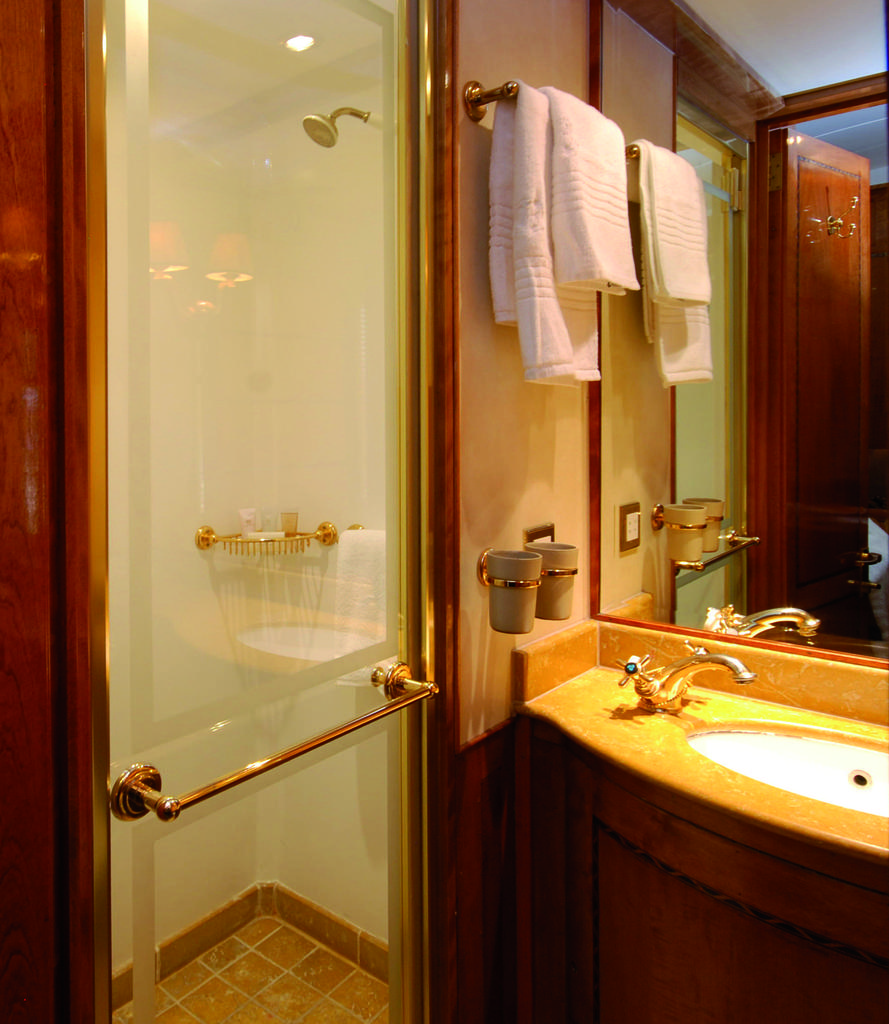What is hanging on the towel rack in the image? There is a towel on a towel rack in the image. What can be seen near the towel rack? There is a door in the image. What is located near the door? There is a sink with a tap in the image. What is another feature of the room in the image? There is a shower in the image. What type of sail can be seen on the towel in the image? There is no sail present on the towel in the image. 